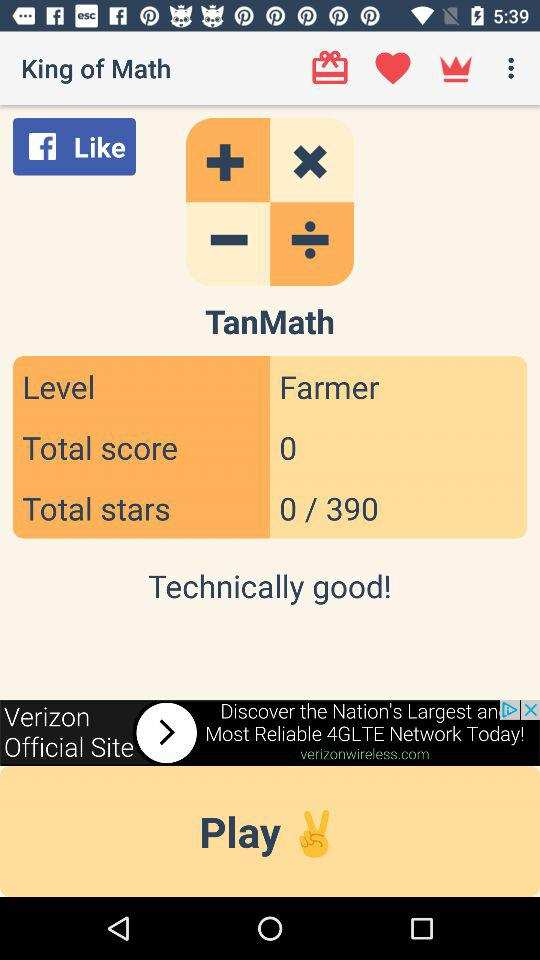What is the total score of the current level?
Answer the question using a single word or phrase. 0 